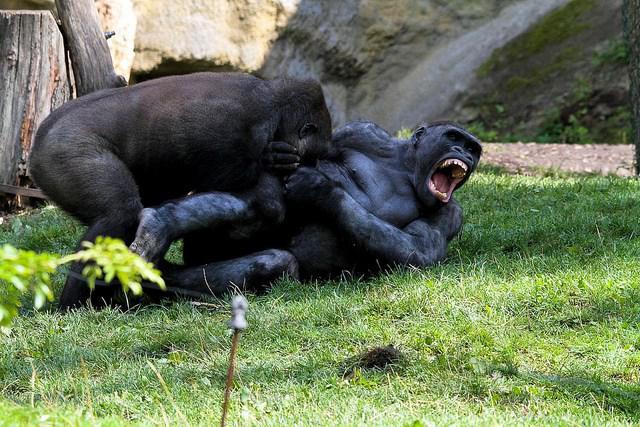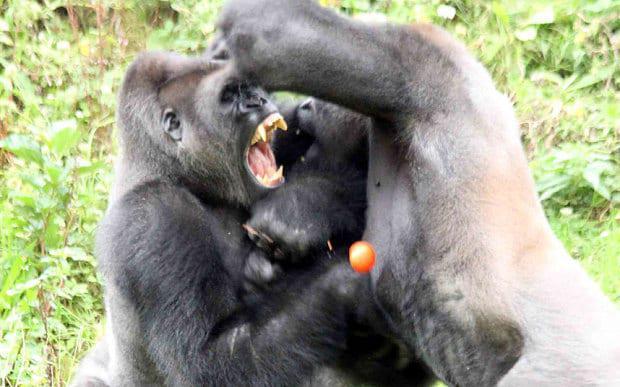The first image is the image on the left, the second image is the image on the right. Analyze the images presented: Is the assertion "Two animals are standing up in each of the images." valid? Answer yes or no. No. 